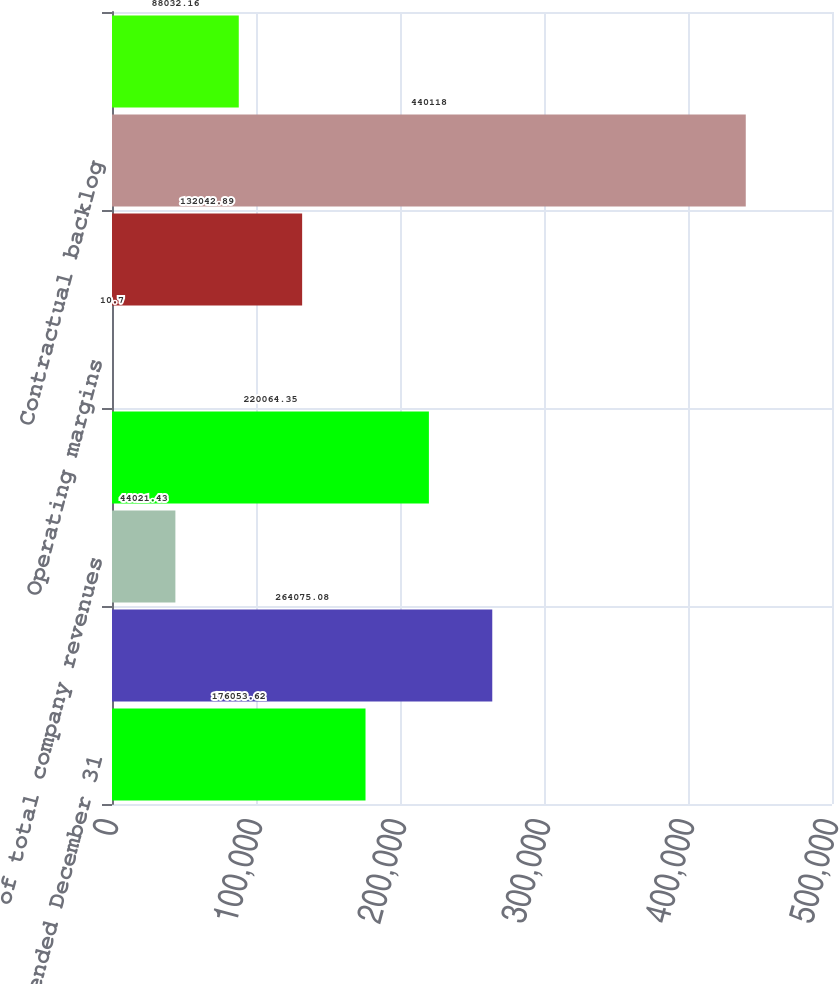Convert chart to OTSL. <chart><loc_0><loc_0><loc_500><loc_500><bar_chart><fcel>Years ended December 31<fcel>Revenues<fcel>of total company revenues<fcel>Earnings from operations<fcel>Operating margins<fcel>Research and development<fcel>Contractual backlog<fcel>Unobligated backlog<nl><fcel>176054<fcel>264075<fcel>44021.4<fcel>220064<fcel>10.7<fcel>132043<fcel>440118<fcel>88032.2<nl></chart> 